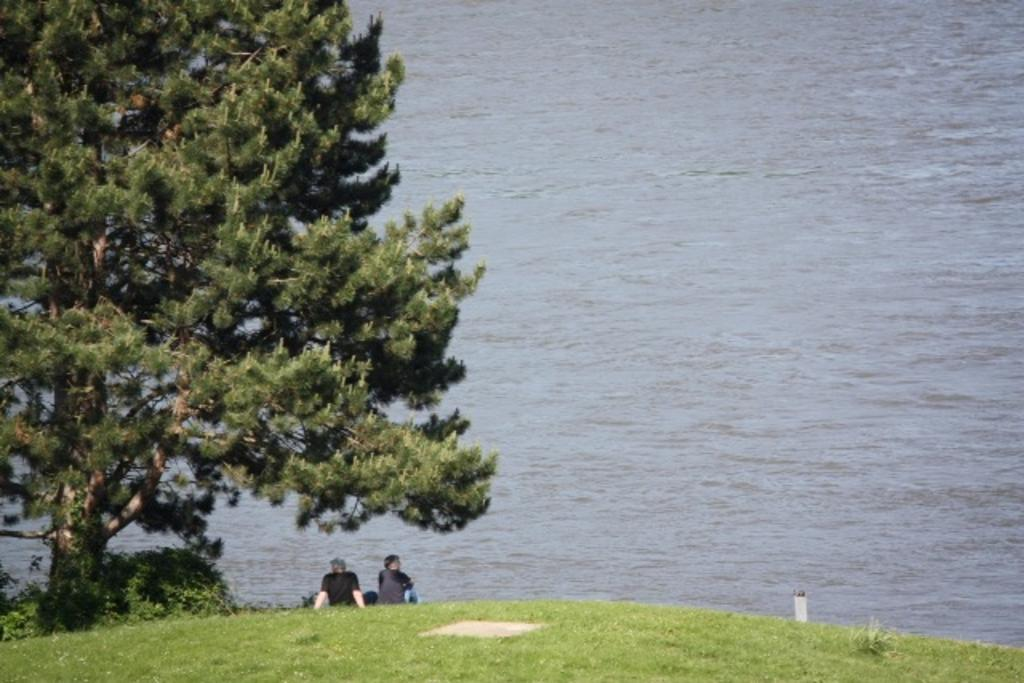How many people are in the image? There are two people in the image. What are the people doing in the image? The people are sitting on the grass. What is located beside the people? There is a tree beside the people. What is visible in front of the people? There is a lake in front of the people. What type of calculator can be seen on the tray in the image? There is no calculator or tray present in the image. 